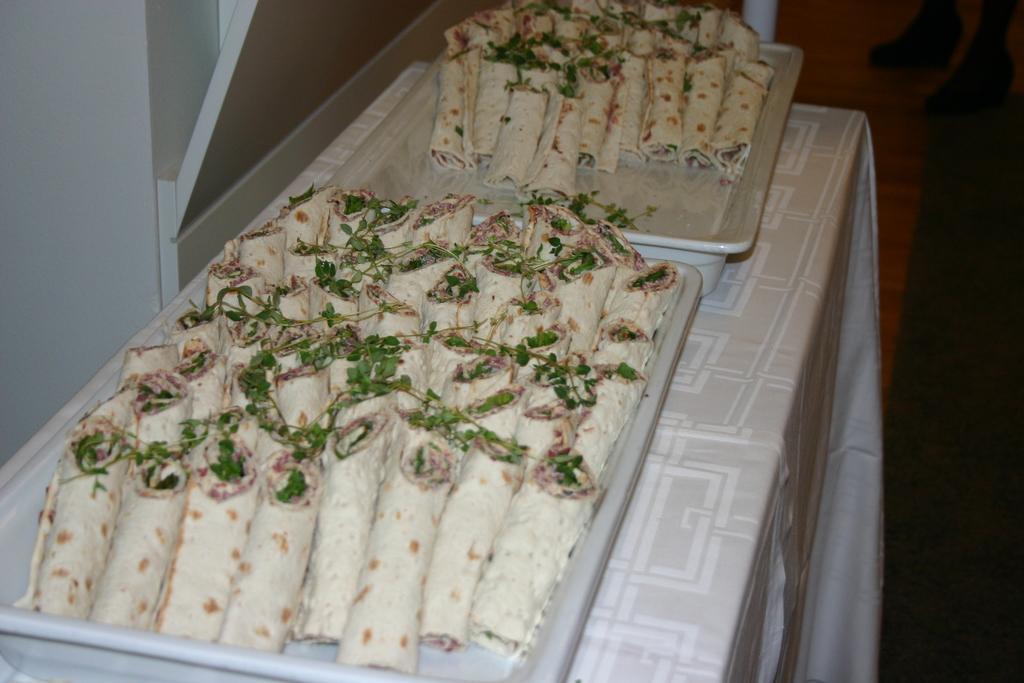How would you summarize this image in a sentence or two? In this image we can see some food items are kept in the tray which are placed on the table having a white color table cloth on it. The background of the image is dark. 